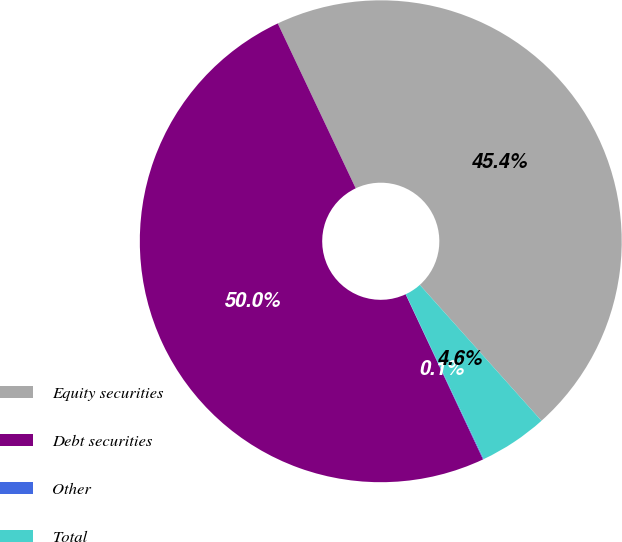Convert chart to OTSL. <chart><loc_0><loc_0><loc_500><loc_500><pie_chart><fcel>Equity securities<fcel>Debt securities<fcel>Other<fcel>Total<nl><fcel>45.41%<fcel>49.95%<fcel>0.05%<fcel>4.59%<nl></chart> 